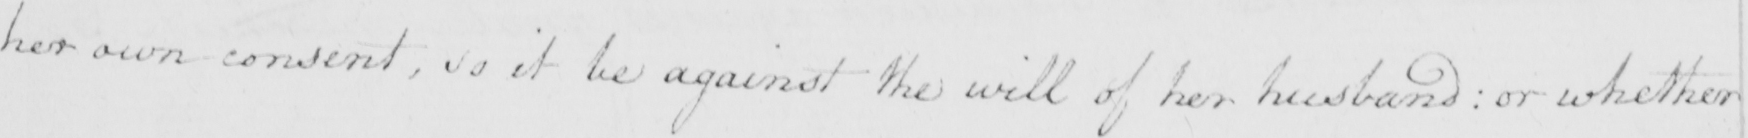What does this handwritten line say? her own consent , so it be against the will of her husband :  or whether 